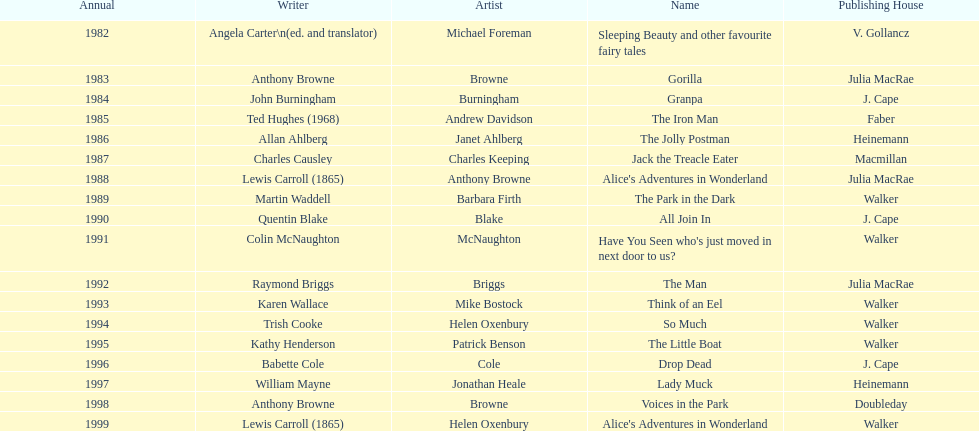What is the only title listed for 1999? Alice's Adventures in Wonderland. 